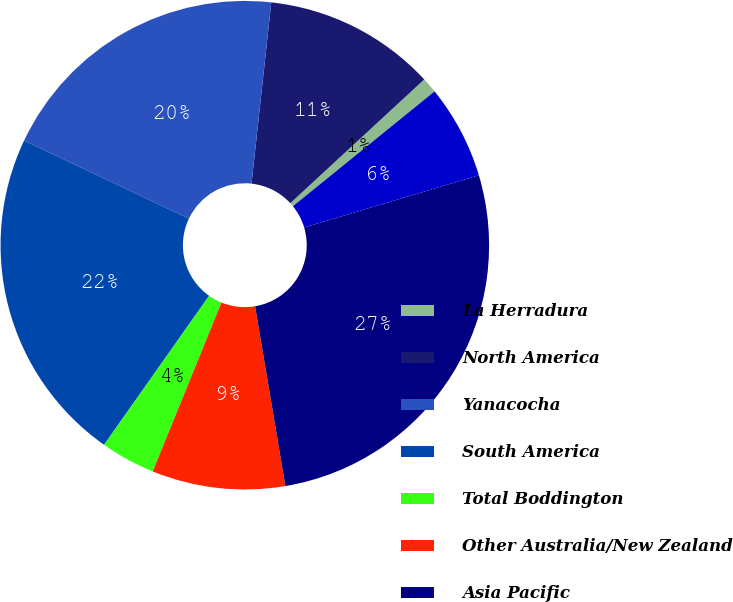<chart> <loc_0><loc_0><loc_500><loc_500><pie_chart><fcel>La Herradura<fcel>North America<fcel>Yanacocha<fcel>South America<fcel>Total Boddington<fcel>Other Australia/New Zealand<fcel>Asia Pacific<fcel>Africa<nl><fcel>1.03%<fcel>11.4%<fcel>19.68%<fcel>22.27%<fcel>3.62%<fcel>8.81%<fcel>26.96%<fcel>6.22%<nl></chart> 